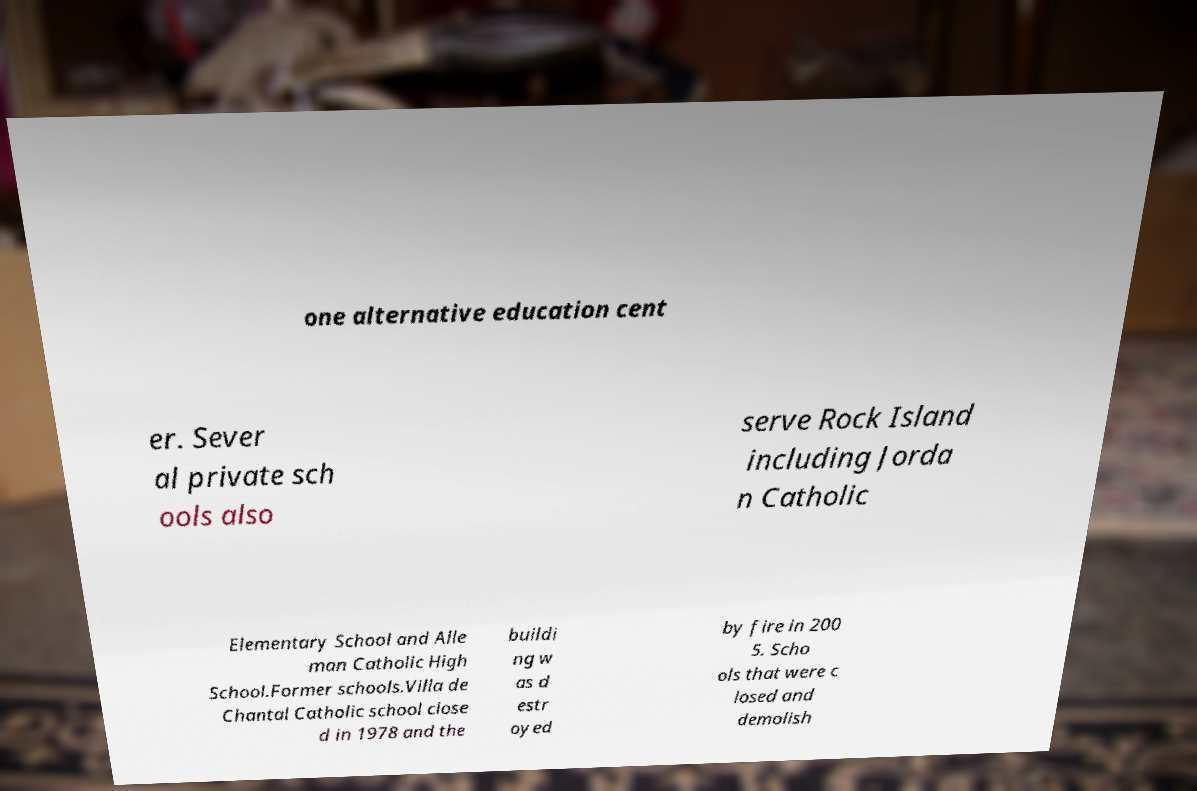For documentation purposes, I need the text within this image transcribed. Could you provide that? one alternative education cent er. Sever al private sch ools also serve Rock Island including Jorda n Catholic Elementary School and Alle man Catholic High School.Former schools.Villa de Chantal Catholic school close d in 1978 and the buildi ng w as d estr oyed by fire in 200 5. Scho ols that were c losed and demolish 